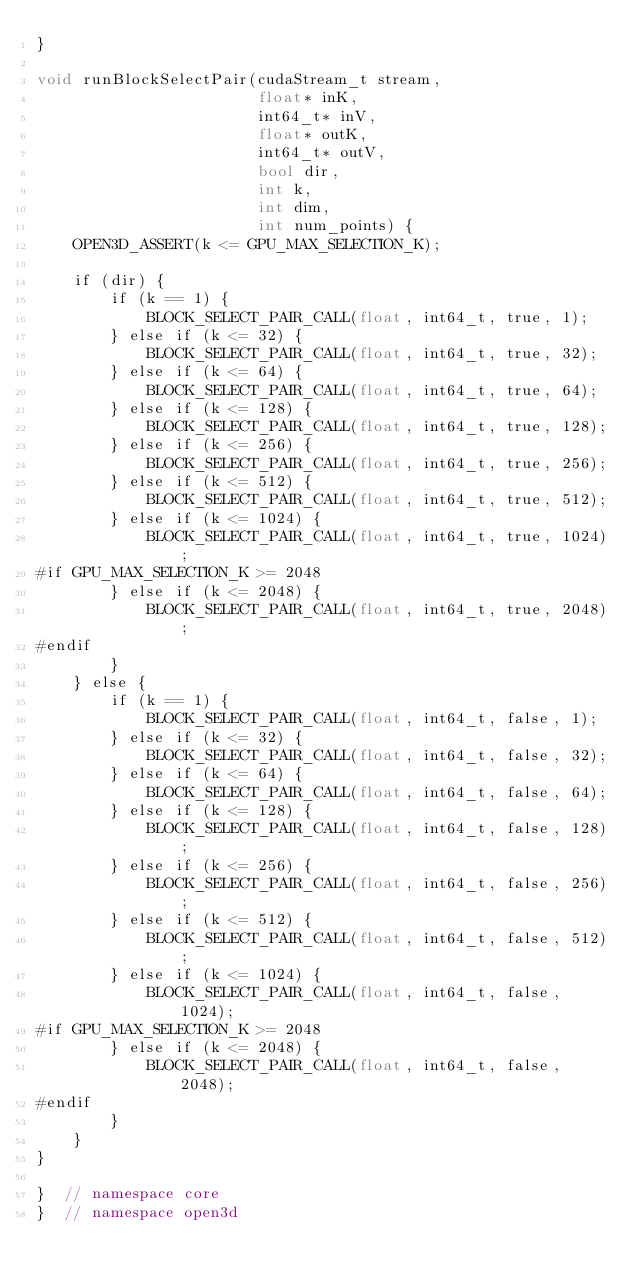<code> <loc_0><loc_0><loc_500><loc_500><_Cuda_>}

void runBlockSelectPair(cudaStream_t stream,
                        float* inK,
                        int64_t* inV,
                        float* outK,
                        int64_t* outV,
                        bool dir,
                        int k,
                        int dim,
                        int num_points) {
    OPEN3D_ASSERT(k <= GPU_MAX_SELECTION_K);

    if (dir) {
        if (k == 1) {
            BLOCK_SELECT_PAIR_CALL(float, int64_t, true, 1);
        } else if (k <= 32) {
            BLOCK_SELECT_PAIR_CALL(float, int64_t, true, 32);
        } else if (k <= 64) {
            BLOCK_SELECT_PAIR_CALL(float, int64_t, true, 64);
        } else if (k <= 128) {
            BLOCK_SELECT_PAIR_CALL(float, int64_t, true, 128);
        } else if (k <= 256) {
            BLOCK_SELECT_PAIR_CALL(float, int64_t, true, 256);
        } else if (k <= 512) {
            BLOCK_SELECT_PAIR_CALL(float, int64_t, true, 512);
        } else if (k <= 1024) {
            BLOCK_SELECT_PAIR_CALL(float, int64_t, true, 1024);
#if GPU_MAX_SELECTION_K >= 2048
        } else if (k <= 2048) {
            BLOCK_SELECT_PAIR_CALL(float, int64_t, true, 2048);
#endif
        }
    } else {
        if (k == 1) {
            BLOCK_SELECT_PAIR_CALL(float, int64_t, false, 1);
        } else if (k <= 32) {
            BLOCK_SELECT_PAIR_CALL(float, int64_t, false, 32);
        } else if (k <= 64) {
            BLOCK_SELECT_PAIR_CALL(float, int64_t, false, 64);
        } else if (k <= 128) {
            BLOCK_SELECT_PAIR_CALL(float, int64_t, false, 128);
        } else if (k <= 256) {
            BLOCK_SELECT_PAIR_CALL(float, int64_t, false, 256);
        } else if (k <= 512) {
            BLOCK_SELECT_PAIR_CALL(float, int64_t, false, 512);
        } else if (k <= 1024) {
            BLOCK_SELECT_PAIR_CALL(float, int64_t, false, 1024);
#if GPU_MAX_SELECTION_K >= 2048
        } else if (k <= 2048) {
            BLOCK_SELECT_PAIR_CALL(float, int64_t, false, 2048);
#endif
        }
    }
}

}  // namespace core
}  // namespace open3d
</code> 